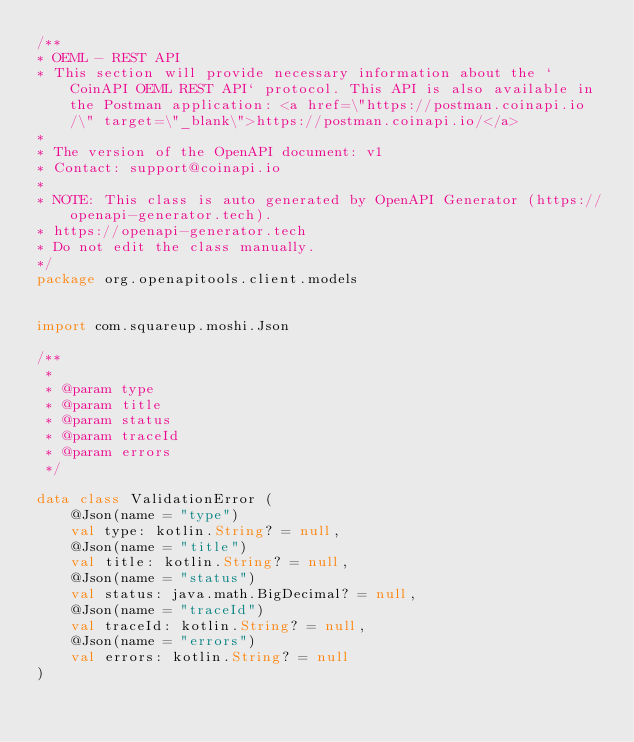<code> <loc_0><loc_0><loc_500><loc_500><_Kotlin_>/**
* OEML - REST API
* This section will provide necessary information about the `CoinAPI OEML REST API` protocol. This API is also available in the Postman application: <a href=\"https://postman.coinapi.io/\" target=\"_blank\">https://postman.coinapi.io/</a>       
*
* The version of the OpenAPI document: v1
* Contact: support@coinapi.io
*
* NOTE: This class is auto generated by OpenAPI Generator (https://openapi-generator.tech).
* https://openapi-generator.tech
* Do not edit the class manually.
*/
package org.openapitools.client.models


import com.squareup.moshi.Json

/**
 * 
 * @param type 
 * @param title 
 * @param status 
 * @param traceId 
 * @param errors 
 */

data class ValidationError (
    @Json(name = "type")
    val type: kotlin.String? = null,
    @Json(name = "title")
    val title: kotlin.String? = null,
    @Json(name = "status")
    val status: java.math.BigDecimal? = null,
    @Json(name = "traceId")
    val traceId: kotlin.String? = null,
    @Json(name = "errors")
    val errors: kotlin.String? = null
)

</code> 